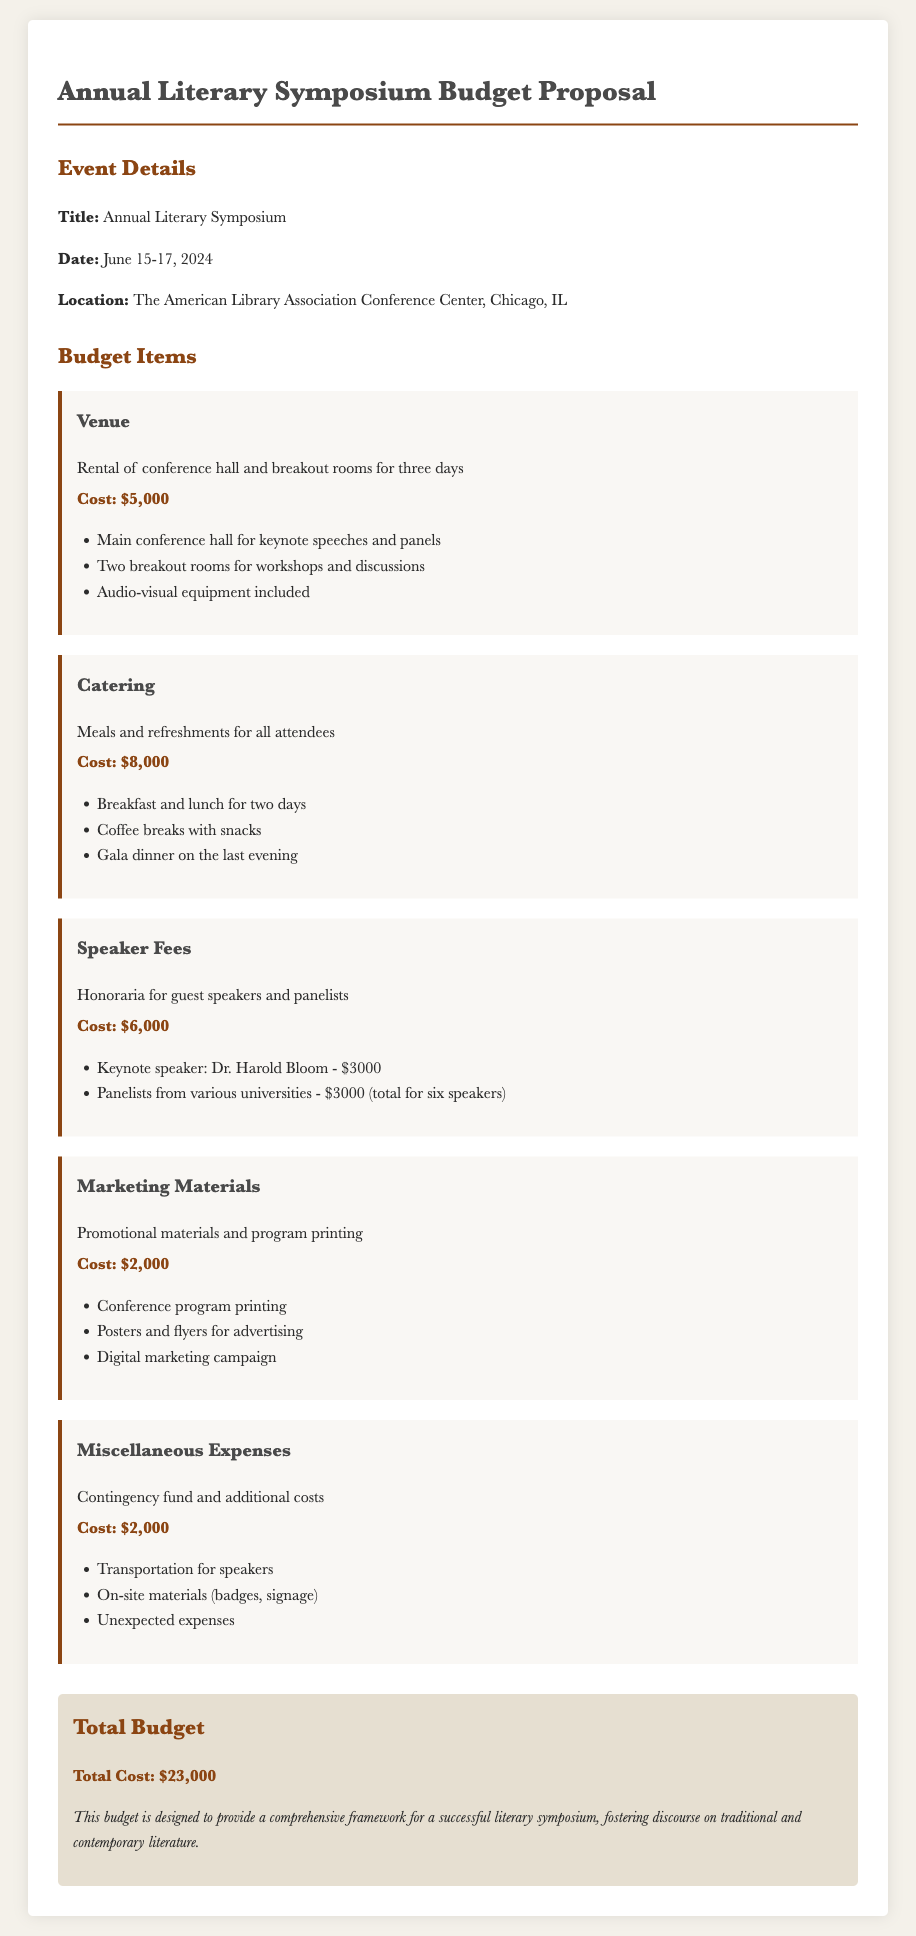What is the event date? The event date is explicitly mentioned in the document as June 15-17, 2024.
Answer: June 15-17, 2024 What is the total budget? The total budget is clearly stated at the end of the document as the sum of all expenses.
Answer: $23,000 What is the venue rental cost? The venue rental cost is specified in the budget items section of the document.
Answer: $5,000 How much is allocated for catering? The budget item specifically lists the catering cost, indicating the total amount set aside.
Answer: $8,000 Who is the keynote speaker? The document names the keynote speaker directly under the speaker fees section.
Answer: Dr. Harold Bloom How many breakout rooms are included in the venue? The budget item for the venue details the number of breakout rooms.
Answer: Two What does the miscellaneous expenses cover? The document provides a brief explanation of what the miscellaneous expenses will be used for, listed in the corresponding section.
Answer: Contingency fund and additional costs What is included in the marketing materials budget? The budget item explains the components covered under marketing materials.
Answer: Promotional materials and program printing How much is budgeted for speaker fees? The cost allocated for speaker fees is detailed in the document under the budget items.
Answer: $6,000 